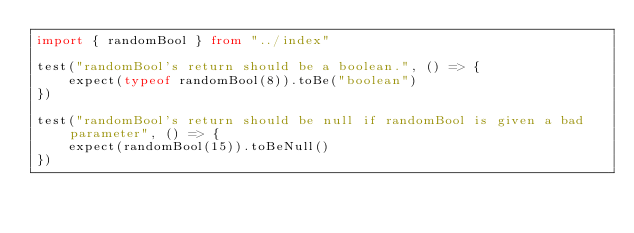<code> <loc_0><loc_0><loc_500><loc_500><_TypeScript_>import { randomBool } from "../index"

test("randomBool's return should be a boolean.", () => {
    expect(typeof randomBool(8)).toBe("boolean")
})

test("randomBool's return should be null if randomBool is given a bad parameter", () => {
    expect(randomBool(15)).toBeNull()
})
</code> 